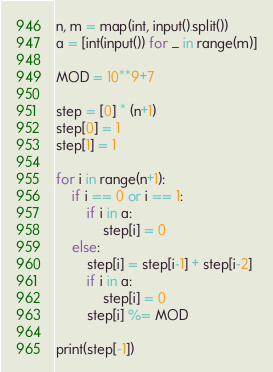<code> <loc_0><loc_0><loc_500><loc_500><_Python_>n, m = map(int, input().split())
a = [int(input()) for _ in range(m)]

MOD = 10**9+7

step = [0] * (n+1)
step[0] = 1
step[1] = 1

for i in range(n+1):
    if i == 0 or i == 1:
        if i in a:
            step[i] = 0
    else:
        step[i] = step[i-1] + step[i-2]
        if i in a:
            step[i] = 0
        step[i] %= MOD

print(step[-1])
</code> 